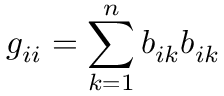Convert formula to latex. <formula><loc_0><loc_0><loc_500><loc_500>g _ { i i } = \sum _ { k = 1 } ^ { n } b _ { i k } b _ { i k }</formula> 